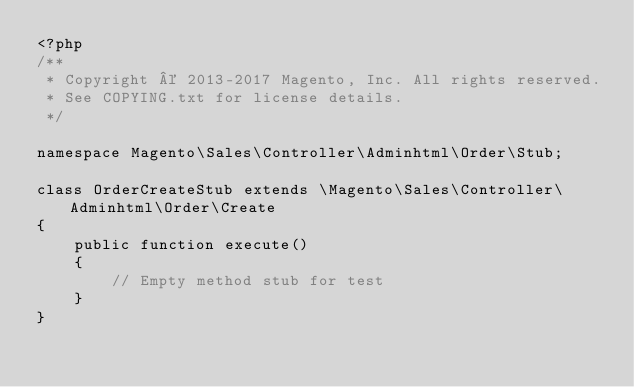Convert code to text. <code><loc_0><loc_0><loc_500><loc_500><_PHP_><?php
/**
 * Copyright © 2013-2017 Magento, Inc. All rights reserved.
 * See COPYING.txt for license details.
 */

namespace Magento\Sales\Controller\Adminhtml\Order\Stub;

class OrderCreateStub extends \Magento\Sales\Controller\Adminhtml\Order\Create
{
    public function execute()
    {
        // Empty method stub for test
    }
}
</code> 